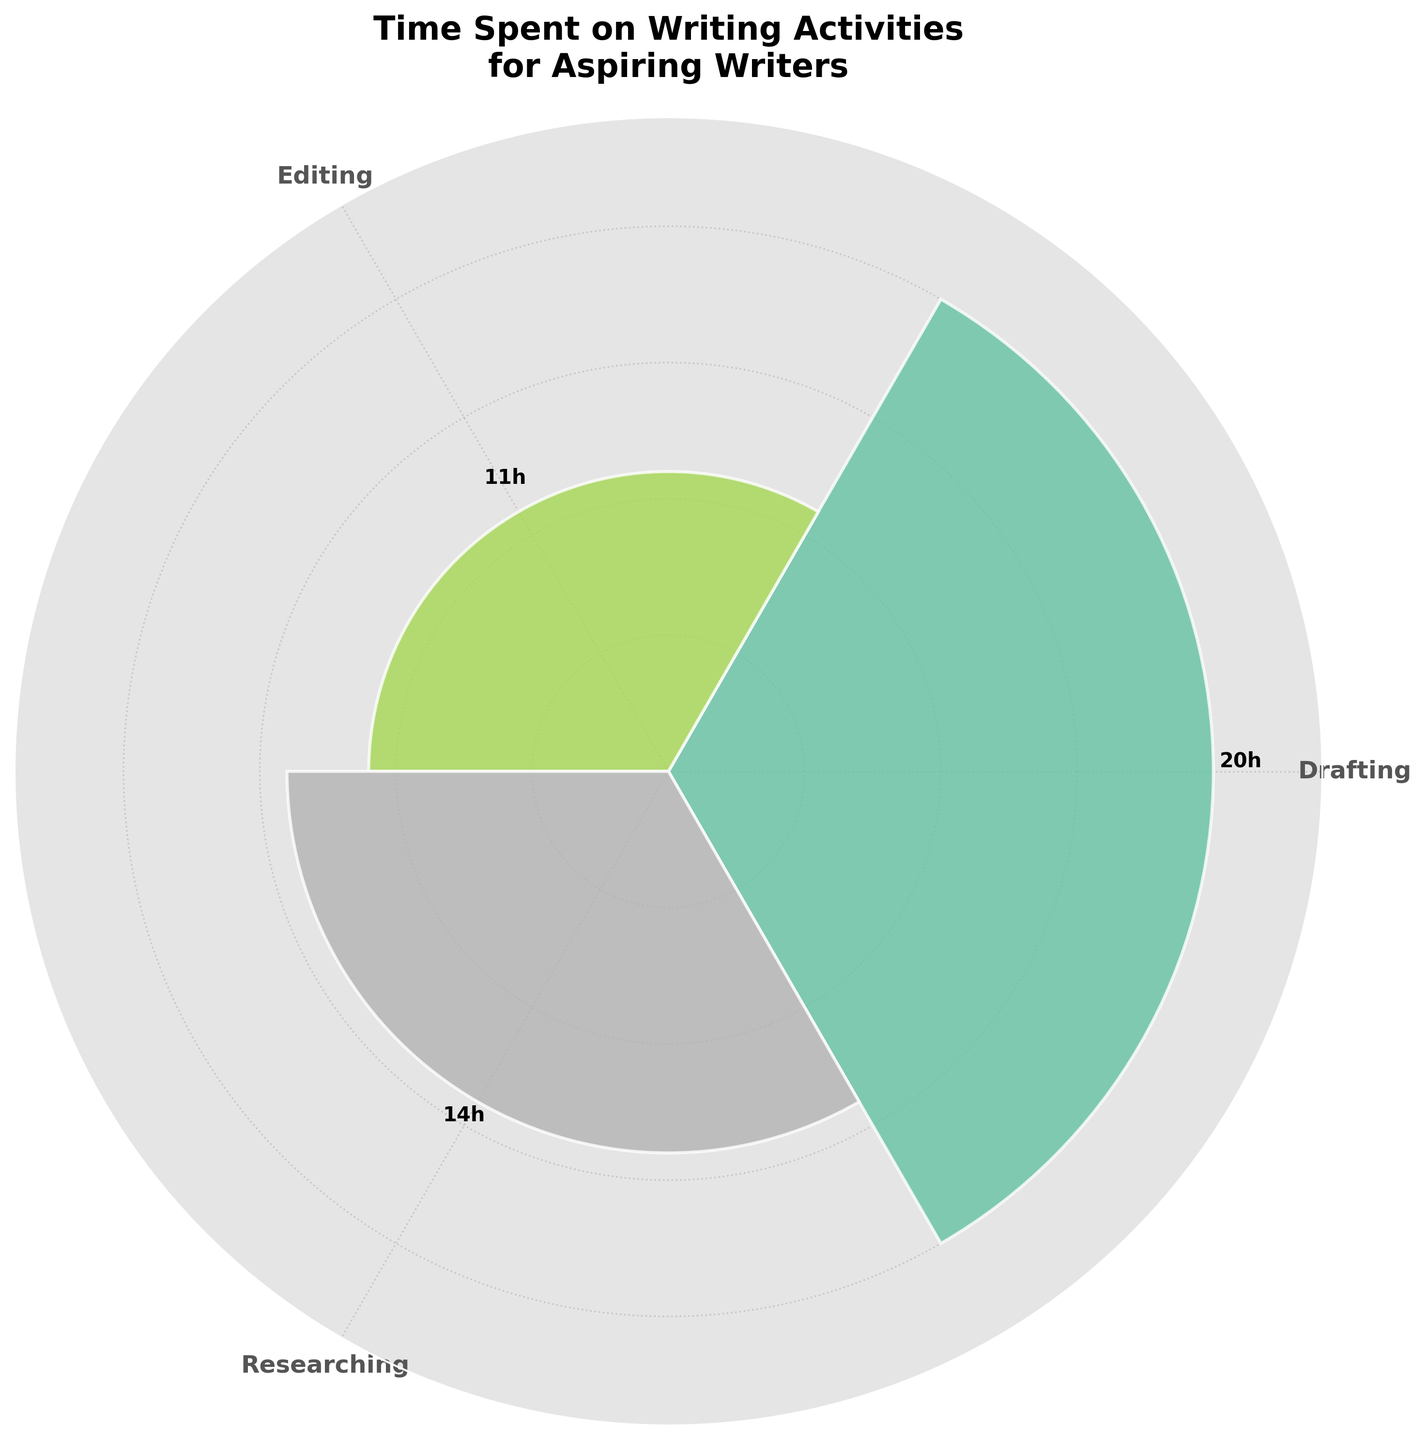What is the title of the figure? The title is usually positioned prominently at the top of the chart. To locate it, read the bold text that summarizes the content of the chart. Here, it states "Time Spent on Writing Activities for Aspiring Writers."
Answer: Time Spent on Writing Activities for Aspiring Writers Which writing activity category has the highest total time spent? By looking at the lengths of the bars, you can easily identify the tallest bar. The category associated with this bar is "Drafting."
Answer: Drafting What is the total time spent on Editing activities? To determine this, locate the bars labeled "Editing" and add their values. The bars labeled Editing show "Proofreading" with 6 hours and "Grammar & Style Checks" with 5 hours. Summing these amounts gives a total of 11 hours.
Answer: 11 hours How much more time is spent on Initial Drafting compared to Source Verification? Find the values for "Initial Drafting" and "Source Verification" and then subtract the smaller value from the larger one. Initial Drafting is 12 hours, and Source Verification is 4 hours, so the difference is 12 - 4 = 8 hours.
Answer: 8 hours Which activity has the least amount of time spent? Determine the shortest bar on the chart, which represents the activity with the smallest value. The smallest bar corresponds to "Source Verification" with 4 hours.
Answer: Source Verification What is the average time spent on each Drafting activity? To find the average, sum the times for Initial Drafting and Revising Draft, then divide by the number of activities. The times are 12 hours and 8 hours respectively, so (12 + 8) / 2 = 20 / 2 = 10 hours.
Answer: 10 hours Is more time spent on Drafting or Researching activities? Compare the total time spent on Drafting and Researching. Drafting has Initial Drafting (12) + Revising Draft (8) = 20 hours. Researching has Background Reading (10) + Source Verification (4) = 14 hours. Drafting's total is greater.
Answer: Drafting What is the sum of time spent on Proofreading and Background Reading? Add the hours for both activities. Proofreading is 6 hours and Background Reading is 10 hours, so 6 + 10 = 16 hours.
Answer: 16 hours Which Drafting activity has more time spent on it, Initial Drafting or Revising Draft? Compare the time allocations directly. Initial Drafting is allotted 12 hours, whereas Revising Draft is given 8 hours. Initial Drafting has more time spent.
Answer: Initial Drafting 